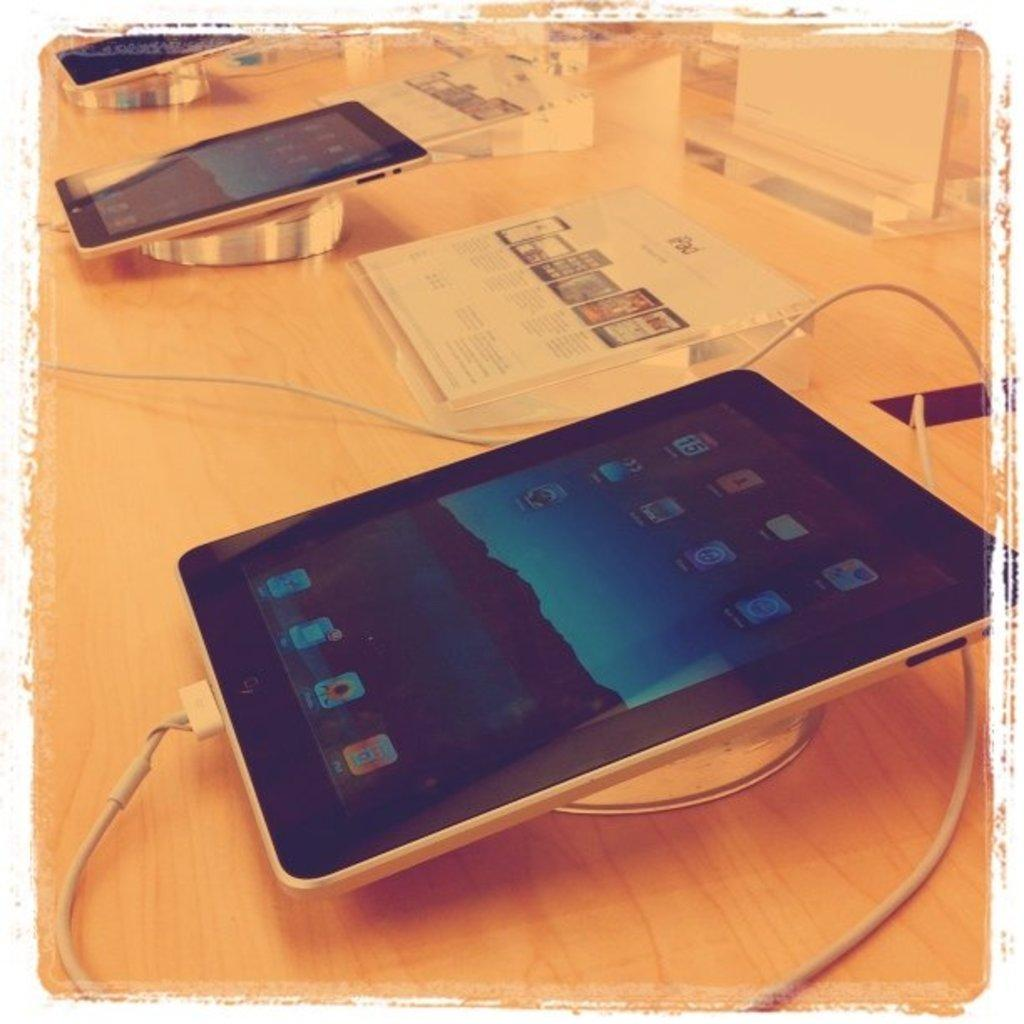How many mobile phones are present in the image? There are three mobile phones in the image. What can be seen on the screens of the mobile phones? There are apps visible on the screens of the mobile phones. What is located in the middle of the image? There is a poster on a table in the middle of the image. Can you tell me who is winning the argument in the image? There is no argument present in the image; it features three mobile phones and a poster on a table. Is there a swing visible in the image? No, there is no swing present in the image. 